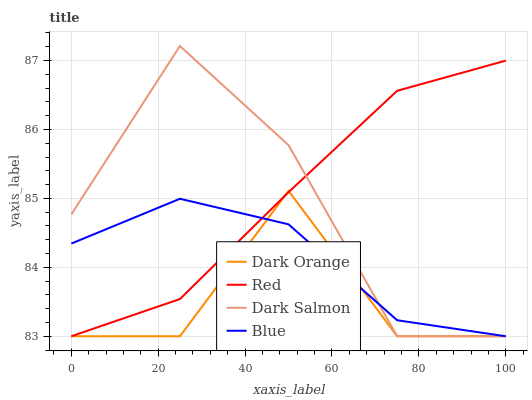Does Dark Orange have the minimum area under the curve?
Answer yes or no. Yes. Does Red have the maximum area under the curve?
Answer yes or no. Yes. Does Dark Salmon have the minimum area under the curve?
Answer yes or no. No. Does Dark Salmon have the maximum area under the curve?
Answer yes or no. No. Is Red the smoothest?
Answer yes or no. Yes. Is Dark Orange the roughest?
Answer yes or no. Yes. Is Dark Salmon the smoothest?
Answer yes or no. No. Is Dark Salmon the roughest?
Answer yes or no. No. Does Blue have the lowest value?
Answer yes or no. Yes. Does Dark Salmon have the highest value?
Answer yes or no. Yes. Does Dark Orange have the highest value?
Answer yes or no. No. Does Dark Orange intersect Blue?
Answer yes or no. Yes. Is Dark Orange less than Blue?
Answer yes or no. No. Is Dark Orange greater than Blue?
Answer yes or no. No. 